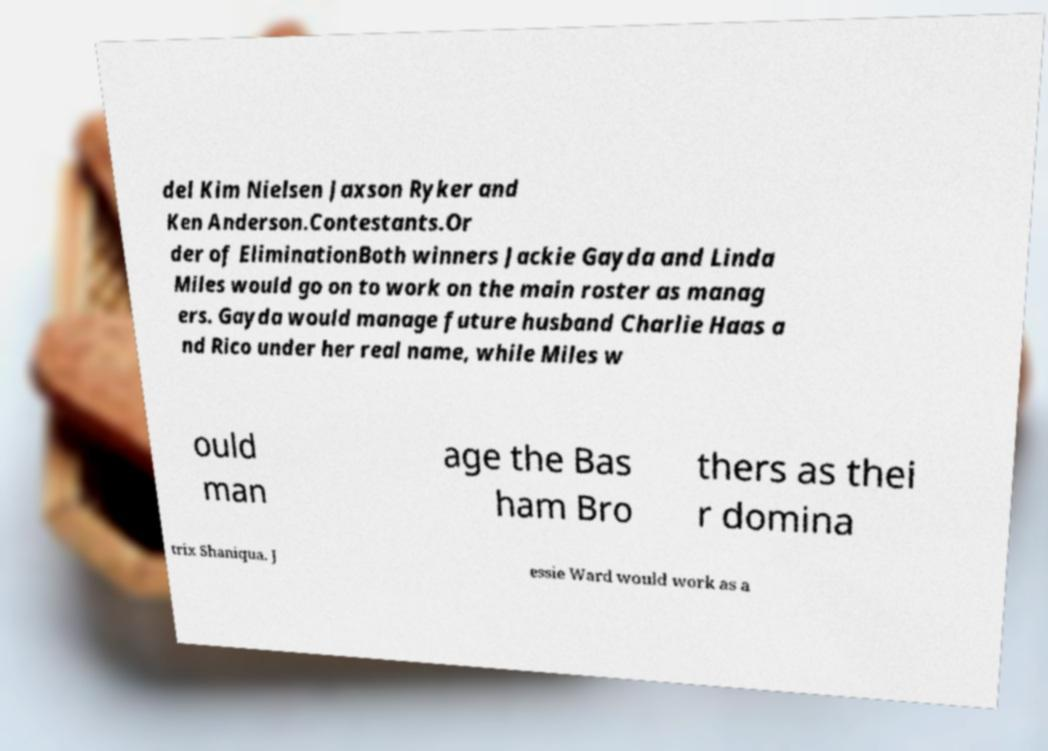What messages or text are displayed in this image? I need them in a readable, typed format. del Kim Nielsen Jaxson Ryker and Ken Anderson.Contestants.Or der of EliminationBoth winners Jackie Gayda and Linda Miles would go on to work on the main roster as manag ers. Gayda would manage future husband Charlie Haas a nd Rico under her real name, while Miles w ould man age the Bas ham Bro thers as thei r domina trix Shaniqua. J essie Ward would work as a 